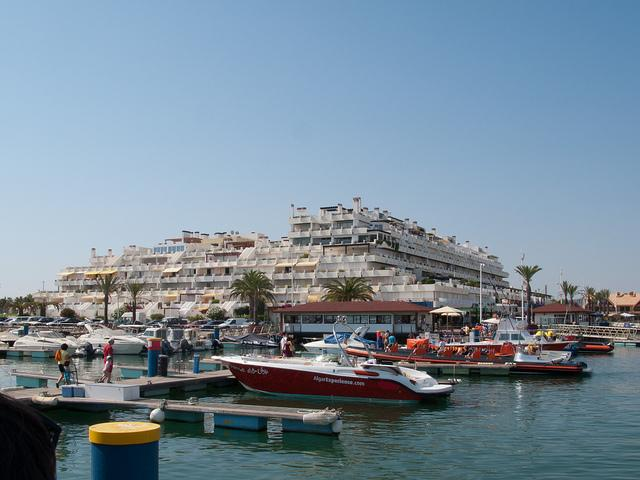What does the side of the nearest boat want you to visit? Please explain your reasoning. website. There is a url ending in .com on the side of the boat. 